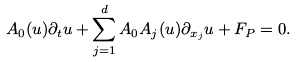Convert formula to latex. <formula><loc_0><loc_0><loc_500><loc_500>A _ { 0 } ( u ) \partial _ { t } u + \sum _ { j = 1 } ^ { d } A _ { 0 } A _ { j } ( u ) \partial _ { x _ { j } } u + F _ { P } = 0 .</formula> 